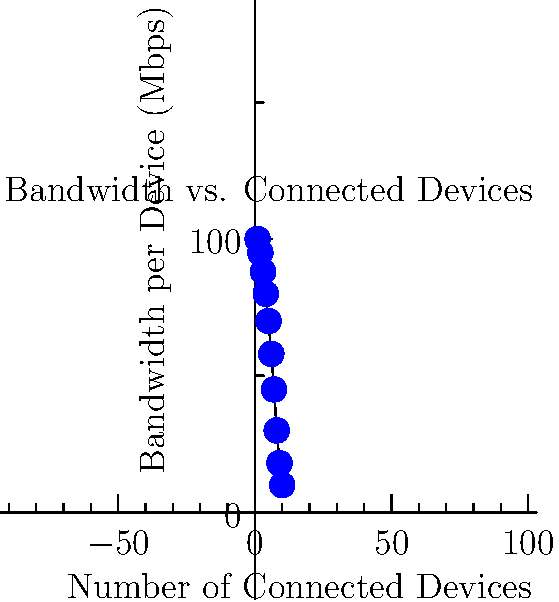Ah, the classic "more devices, less speed" conundrum. Looking at this scatter plot of bandwidth per device versus the number of connected devices, what mathematical function best describes this relationship? Is it:
a) Linear
b) Exponential
c) Logarithmic
d) Hyperbolic

Bonus points if you can explain why without inducing a Wi-Fi-rage incident. Let's break this down with the sarcasm dialed back (temporarily):

1) Observe the shape of the scatter plot. It's clearly not a straight line, so we can rule out a linear function.

2) The curve doesn't show the characteristic rapid decay of an exponential function, so that's out too.

3) A logarithmic function would curve the other way, with a sharp initial drop that levels off. That's not what we see here.

4) What we do see is a curve that starts high and decreases more slowly as it approaches the x-axis, never quite touching it. This is characteristic of a hyperbolic function.

5) Mathematically, a hyperbolic function for this scenario could be expressed as:

   $$B = \frac{k}{n}$$

   Where $B$ is the bandwidth per device, $n$ is the number of devices, and $k$ is a constant representing the total available bandwidth.

6) This makes sense in the real world too. If you have a fixed amount of bandwidth and divide it among more devices, each device gets less, but you can never reach zero (unless your ISP decides to take a coffee break).

So, while you're cursing at your router for the fifth time today, remember: it's just doing its best to divide your precious Mbps hyperbolicall
Answer: d) Hyperbolic 